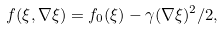Convert formula to latex. <formula><loc_0><loc_0><loc_500><loc_500>f ( \xi , \nabla \xi ) = f _ { 0 } ( \xi ) - \gamma ( \nabla \xi ) ^ { 2 } / 2 ,</formula> 